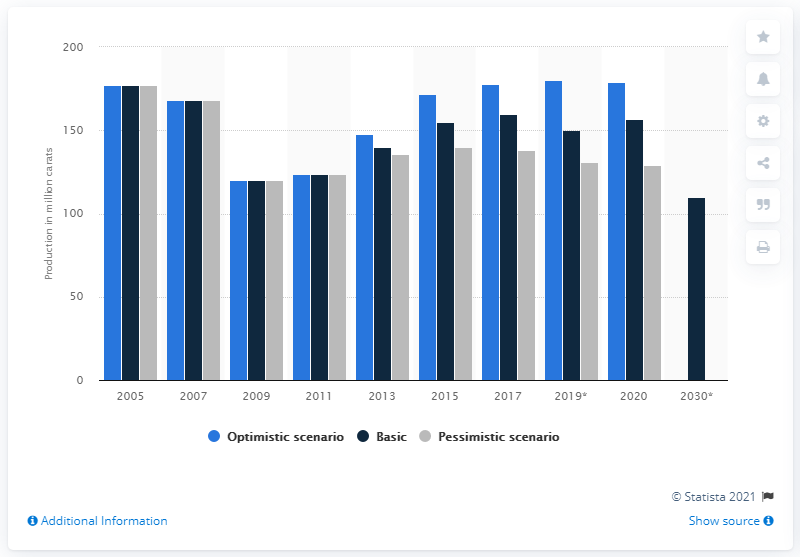Draw attention to some important aspects in this diagram. It is predicted that a large quantity of carats, specifically 138 carats, of diamonds will be produced in the year 2017. 